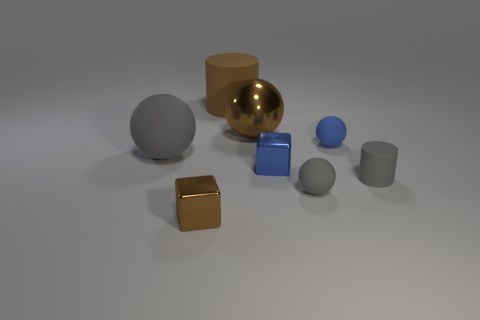Are there any cylinders that are on the right side of the brown metal object that is behind the tiny blue ball?
Offer a very short reply. Yes. What number of balls are either tiny matte objects or tiny red rubber things?
Your answer should be very brief. 2. Are there any other rubber things that have the same shape as the blue matte object?
Offer a very short reply. Yes. What is the shape of the big gray object?
Your answer should be compact. Sphere. How many objects are small blue matte objects or brown metal things?
Your answer should be compact. 3. There is a cylinder that is in front of the large gray matte ball; is its size the same as the rubber cylinder behind the big matte ball?
Offer a terse response. No. How many other objects are there of the same material as the small gray ball?
Your answer should be compact. 4. Is the number of big shiny spheres in front of the large rubber cylinder greater than the number of small brown cubes in front of the brown shiny cube?
Your answer should be compact. Yes. What material is the blue thing that is left of the blue matte ball?
Give a very brief answer. Metal. Is the shape of the blue shiny object the same as the brown matte object?
Provide a succinct answer. No. 